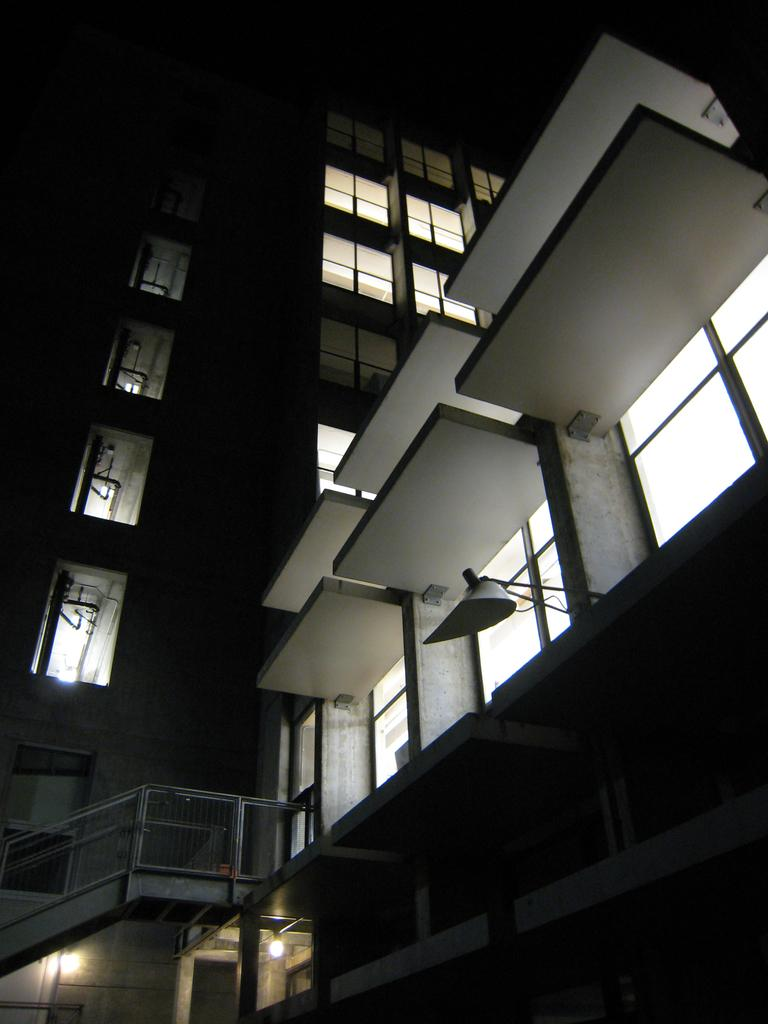What type of structures can be seen in the image? There are buildings in the image. What feature can be observed on the buildings? There are windows visible on the buildings. What else can be seen on the buildings? There are lights visible in the image. How would you describe the overall appearance of the image? The background of the image is dark. What type of fruit is being quartered in the image? There is no fruit present in the image, and therefore no fruit is being quartered. 